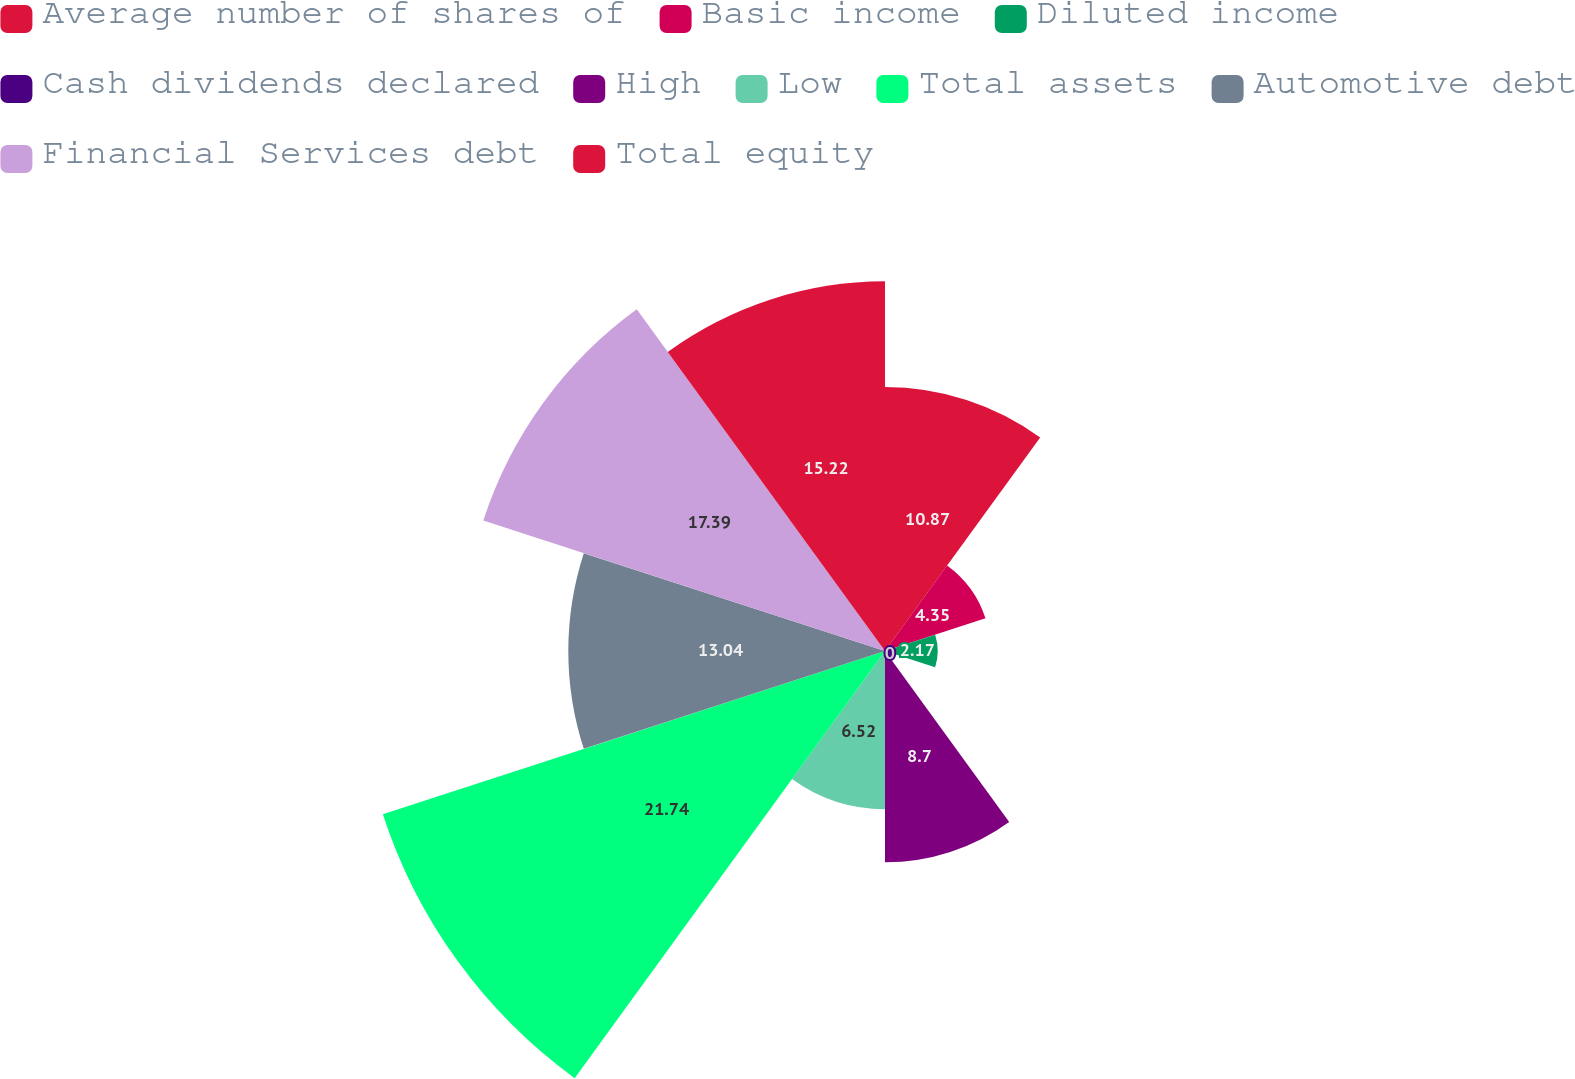Convert chart. <chart><loc_0><loc_0><loc_500><loc_500><pie_chart><fcel>Average number of shares of<fcel>Basic income<fcel>Diluted income<fcel>Cash dividends declared<fcel>High<fcel>Low<fcel>Total assets<fcel>Automotive debt<fcel>Financial Services debt<fcel>Total equity<nl><fcel>10.87%<fcel>4.35%<fcel>2.17%<fcel>0.0%<fcel>8.7%<fcel>6.52%<fcel>21.74%<fcel>13.04%<fcel>17.39%<fcel>15.22%<nl></chart> 